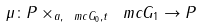Convert formula to latex. <formula><loc_0><loc_0><loc_500><loc_500>\mu \colon P \times _ { a , \ m c { G } _ { 0 } , t } \ m c { G } _ { 1 } \rightarrow P</formula> 